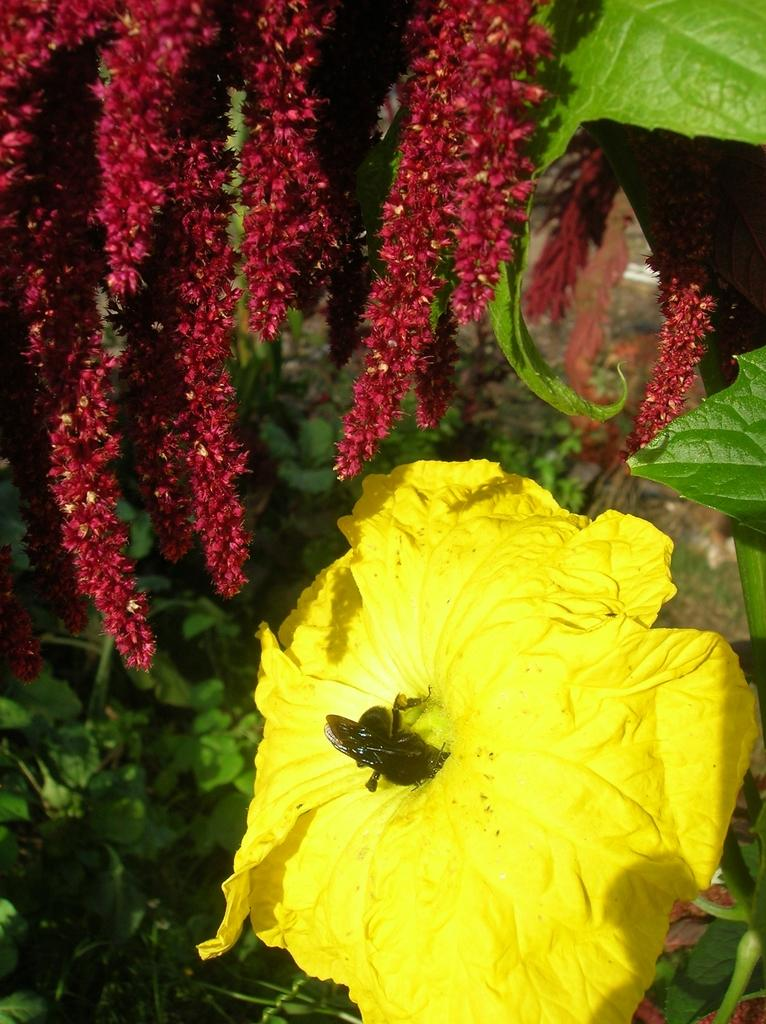What types of flora are present in the image? There are flowers and plants in the image. Can you describe the insect in the image? There is an insect on a yellow flower in the image. What type of leather is visible in the image? There is no leather present in the image. How does the air help the flowers grow in the image? The image does not show the process of the air helping the flowers grow; it only depicts the flowers and plants. 